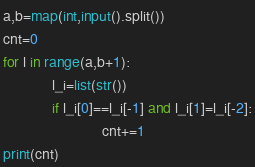Convert code to text. <code><loc_0><loc_0><loc_500><loc_500><_Python_>a,b=map(int,input().split())
cnt=0
for l in range(a,b+1):
            l_i=list(str())
            if l_i[0]==l_i[-1] and l_i[1]=l_i[-2]:
                        cnt+=1
print(cnt)                        
</code> 